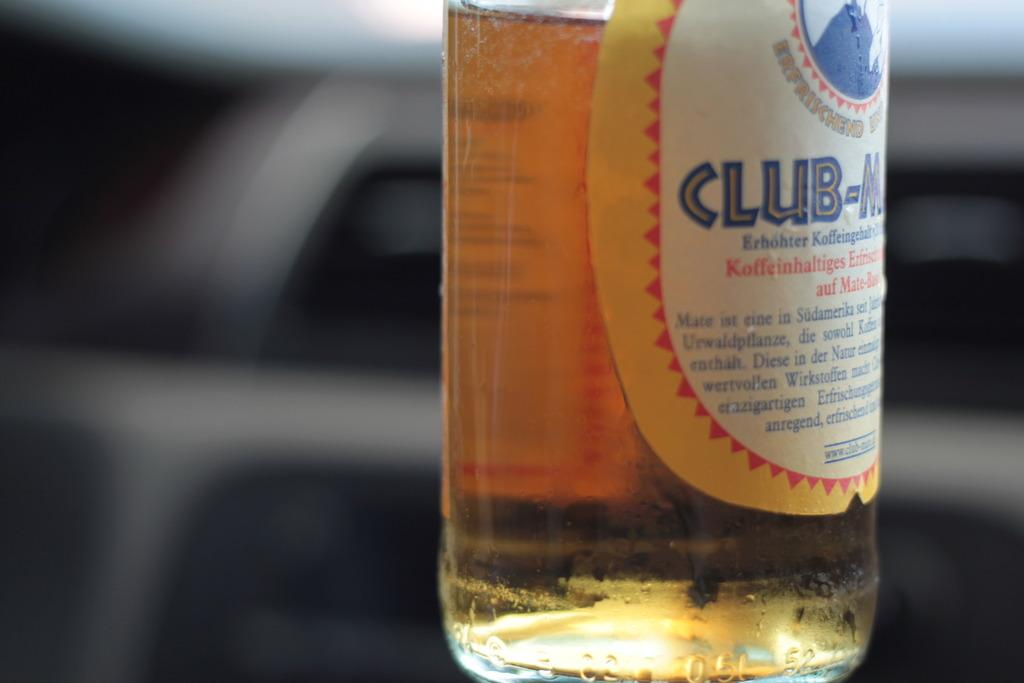<image>
Write a terse but informative summary of the picture. A beverage bottle has the word club on the label and yellow trim around the label. 